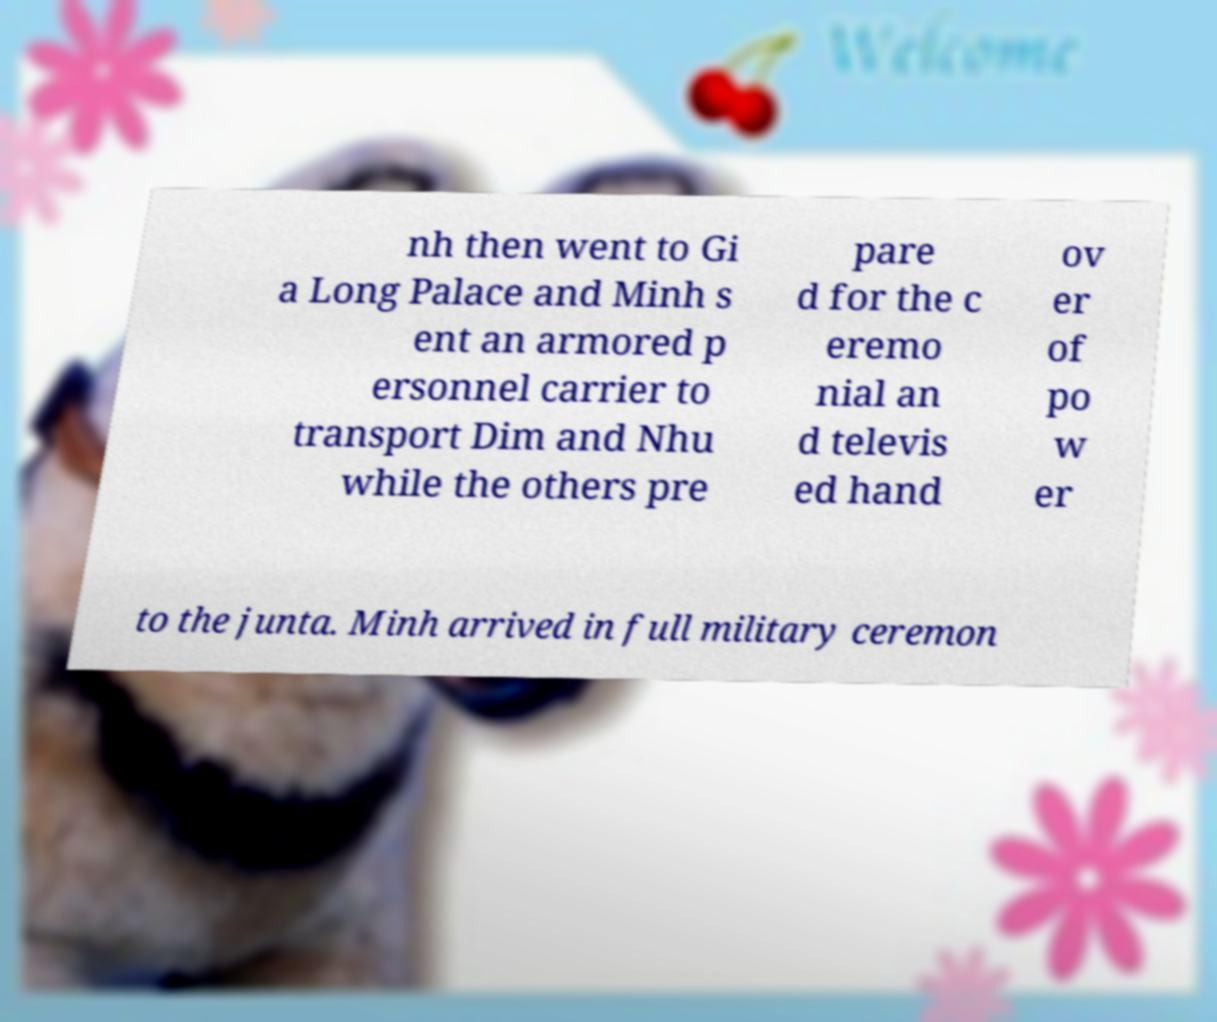What messages or text are displayed in this image? I need them in a readable, typed format. nh then went to Gi a Long Palace and Minh s ent an armored p ersonnel carrier to transport Dim and Nhu while the others pre pare d for the c eremo nial an d televis ed hand ov er of po w er to the junta. Minh arrived in full military ceremon 